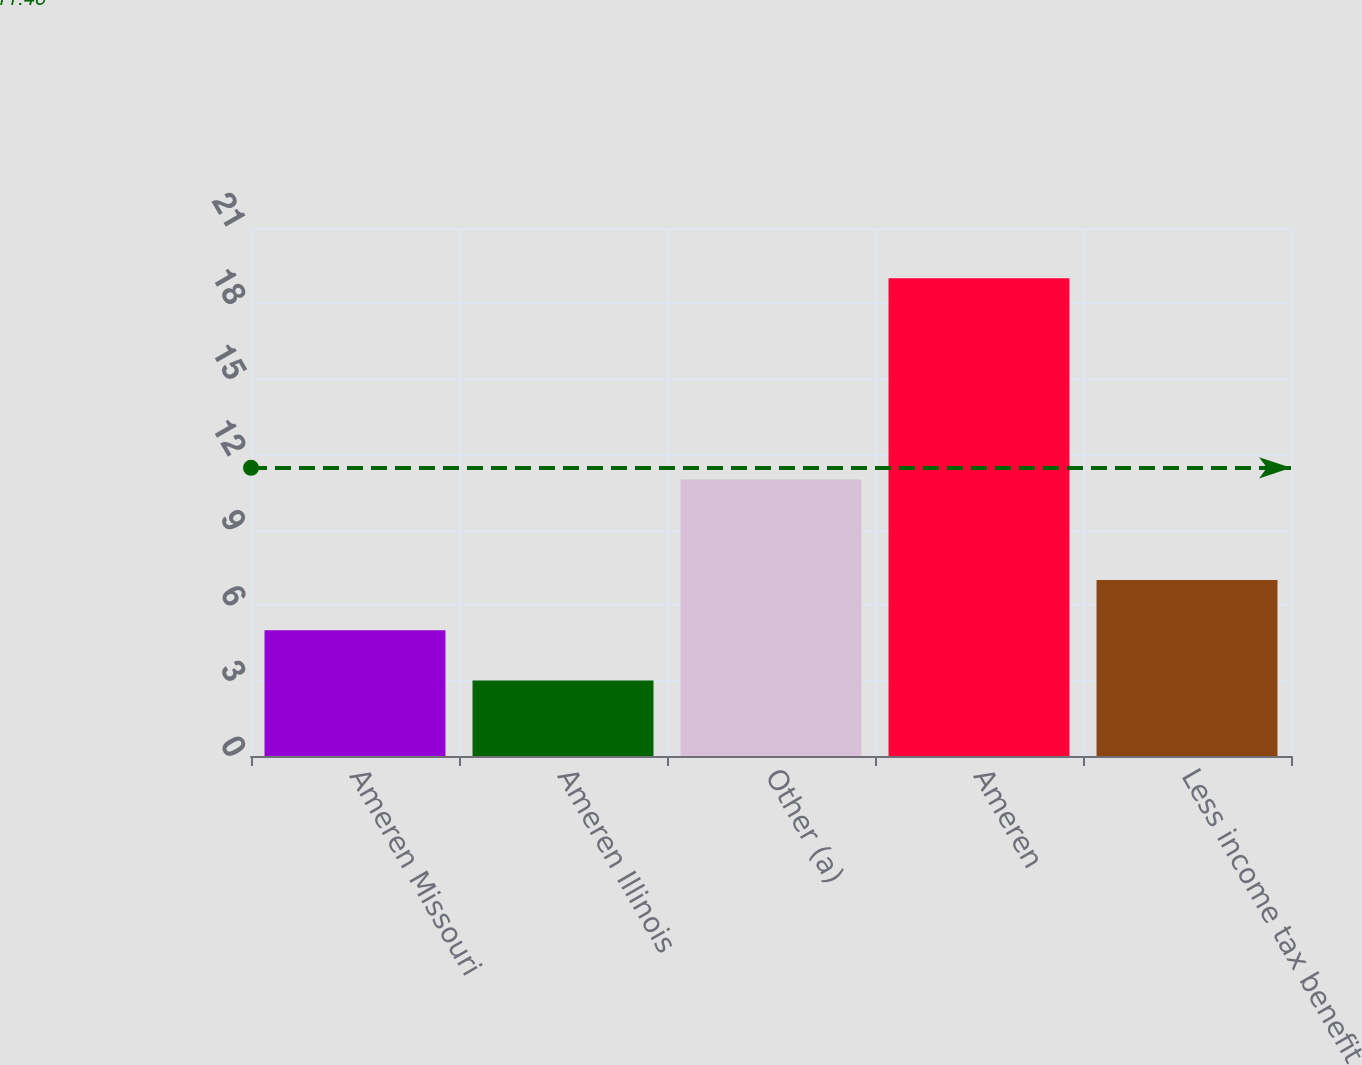<chart> <loc_0><loc_0><loc_500><loc_500><bar_chart><fcel>Ameren Missouri<fcel>Ameren Illinois<fcel>Other (a)<fcel>Ameren<fcel>Less income tax benefit<nl><fcel>5<fcel>3<fcel>11<fcel>19<fcel>7<nl></chart> 